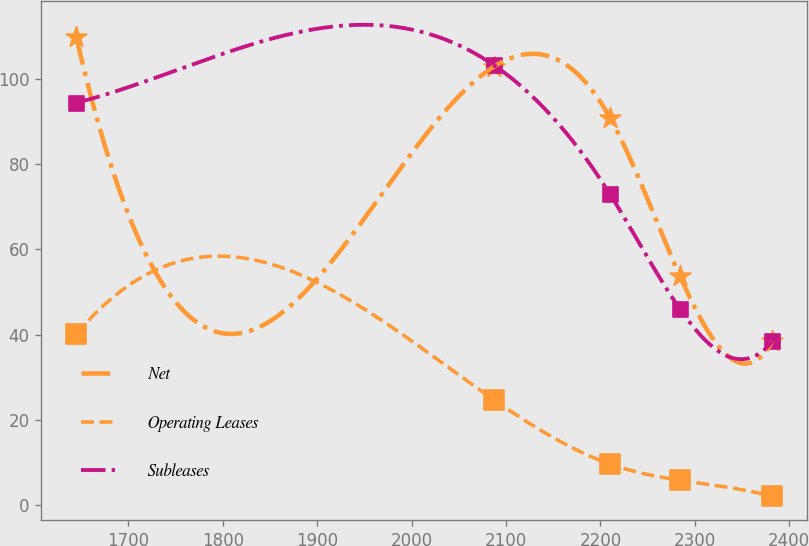Convert chart. <chart><loc_0><loc_0><loc_500><loc_500><line_chart><ecel><fcel>Net<fcel>Operating Leases<fcel>Subleases<nl><fcel>1644.81<fcel>109.94<fcel>40.07<fcel>94.4<nl><fcel>2087.49<fcel>102.92<fcel>24.66<fcel>103.19<nl><fcel>2210.23<fcel>90.85<fcel>9.62<fcel>72.93<nl><fcel>2283.97<fcel>53.85<fcel>5.82<fcel>46.08<nl><fcel>2382.25<fcel>38.41<fcel>2.02<fcel>38.42<nl></chart> 